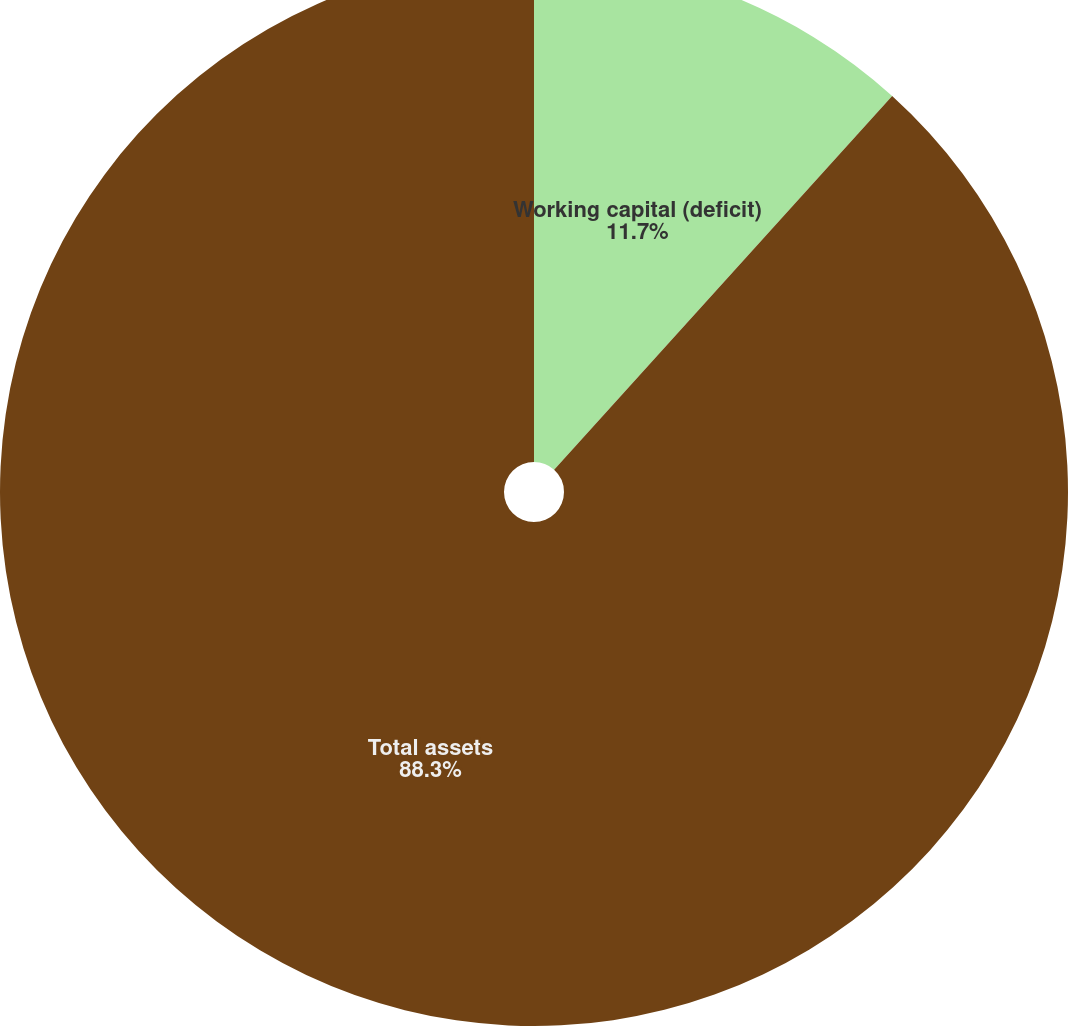Convert chart to OTSL. <chart><loc_0><loc_0><loc_500><loc_500><pie_chart><fcel>Working capital (deficit)<fcel>Total assets<nl><fcel>11.7%<fcel>88.3%<nl></chart> 